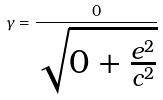Convert formula to latex. <formula><loc_0><loc_0><loc_500><loc_500>\gamma = \frac { 0 } { \sqrt { 0 + \frac { e ^ { 2 } } { c ^ { 2 } } } }</formula> 